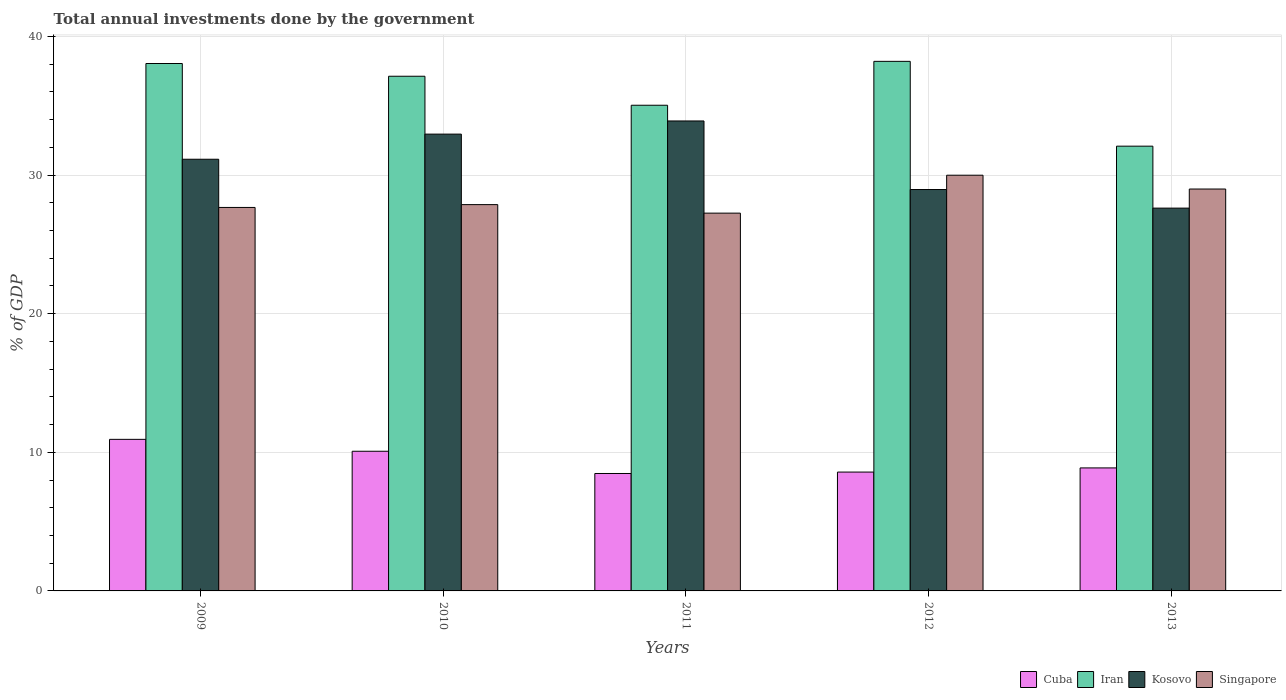Are the number of bars per tick equal to the number of legend labels?
Your answer should be very brief. Yes. Are the number of bars on each tick of the X-axis equal?
Keep it short and to the point. Yes. How many bars are there on the 5th tick from the left?
Ensure brevity in your answer.  4. How many bars are there on the 2nd tick from the right?
Give a very brief answer. 4. What is the total annual investments done by the government in Singapore in 2012?
Keep it short and to the point. 29.99. Across all years, what is the maximum total annual investments done by the government in Iran?
Keep it short and to the point. 38.21. Across all years, what is the minimum total annual investments done by the government in Singapore?
Offer a terse response. 27.26. What is the total total annual investments done by the government in Iran in the graph?
Offer a terse response. 180.51. What is the difference between the total annual investments done by the government in Cuba in 2009 and that in 2013?
Your response must be concise. 2.06. What is the difference between the total annual investments done by the government in Iran in 2011 and the total annual investments done by the government in Cuba in 2012?
Provide a succinct answer. 26.46. What is the average total annual investments done by the government in Kosovo per year?
Your answer should be compact. 30.92. In the year 2012, what is the difference between the total annual investments done by the government in Singapore and total annual investments done by the government in Cuba?
Offer a very short reply. 21.42. What is the ratio of the total annual investments done by the government in Singapore in 2009 to that in 2013?
Offer a very short reply. 0.95. Is the difference between the total annual investments done by the government in Singapore in 2012 and 2013 greater than the difference between the total annual investments done by the government in Cuba in 2012 and 2013?
Ensure brevity in your answer.  Yes. What is the difference between the highest and the second highest total annual investments done by the government in Iran?
Your response must be concise. 0.16. What is the difference between the highest and the lowest total annual investments done by the government in Singapore?
Give a very brief answer. 2.74. In how many years, is the total annual investments done by the government in Kosovo greater than the average total annual investments done by the government in Kosovo taken over all years?
Offer a terse response. 3. What does the 1st bar from the left in 2010 represents?
Your response must be concise. Cuba. What does the 4th bar from the right in 2011 represents?
Give a very brief answer. Cuba. Is it the case that in every year, the sum of the total annual investments done by the government in Iran and total annual investments done by the government in Singapore is greater than the total annual investments done by the government in Kosovo?
Offer a terse response. Yes. Does the graph contain grids?
Your response must be concise. Yes. Where does the legend appear in the graph?
Your answer should be very brief. Bottom right. How are the legend labels stacked?
Give a very brief answer. Horizontal. What is the title of the graph?
Offer a terse response. Total annual investments done by the government. What is the label or title of the X-axis?
Provide a succinct answer. Years. What is the label or title of the Y-axis?
Offer a terse response. % of GDP. What is the % of GDP in Cuba in 2009?
Your answer should be very brief. 10.93. What is the % of GDP of Iran in 2009?
Keep it short and to the point. 38.05. What is the % of GDP of Kosovo in 2009?
Offer a terse response. 31.14. What is the % of GDP of Singapore in 2009?
Your answer should be very brief. 27.67. What is the % of GDP of Cuba in 2010?
Keep it short and to the point. 10.08. What is the % of GDP in Iran in 2010?
Ensure brevity in your answer.  37.13. What is the % of GDP in Kosovo in 2010?
Keep it short and to the point. 32.96. What is the % of GDP of Singapore in 2010?
Make the answer very short. 27.87. What is the % of GDP in Cuba in 2011?
Make the answer very short. 8.47. What is the % of GDP of Iran in 2011?
Ensure brevity in your answer.  35.04. What is the % of GDP of Kosovo in 2011?
Offer a very short reply. 33.91. What is the % of GDP in Singapore in 2011?
Offer a very short reply. 27.26. What is the % of GDP in Cuba in 2012?
Your answer should be very brief. 8.57. What is the % of GDP of Iran in 2012?
Ensure brevity in your answer.  38.21. What is the % of GDP of Kosovo in 2012?
Your answer should be very brief. 28.96. What is the % of GDP in Singapore in 2012?
Ensure brevity in your answer.  29.99. What is the % of GDP of Cuba in 2013?
Make the answer very short. 8.87. What is the % of GDP in Iran in 2013?
Ensure brevity in your answer.  32.09. What is the % of GDP of Kosovo in 2013?
Ensure brevity in your answer.  27.62. What is the % of GDP of Singapore in 2013?
Make the answer very short. 29. Across all years, what is the maximum % of GDP in Cuba?
Make the answer very short. 10.93. Across all years, what is the maximum % of GDP in Iran?
Provide a short and direct response. 38.21. Across all years, what is the maximum % of GDP of Kosovo?
Offer a very short reply. 33.91. Across all years, what is the maximum % of GDP of Singapore?
Give a very brief answer. 29.99. Across all years, what is the minimum % of GDP of Cuba?
Your response must be concise. 8.47. Across all years, what is the minimum % of GDP of Iran?
Your answer should be very brief. 32.09. Across all years, what is the minimum % of GDP in Kosovo?
Make the answer very short. 27.62. Across all years, what is the minimum % of GDP in Singapore?
Offer a terse response. 27.26. What is the total % of GDP of Cuba in the graph?
Make the answer very short. 46.93. What is the total % of GDP in Iran in the graph?
Give a very brief answer. 180.51. What is the total % of GDP of Kosovo in the graph?
Your response must be concise. 154.58. What is the total % of GDP of Singapore in the graph?
Give a very brief answer. 141.78. What is the difference between the % of GDP in Cuba in 2009 and that in 2010?
Keep it short and to the point. 0.86. What is the difference between the % of GDP of Iran in 2009 and that in 2010?
Your response must be concise. 0.92. What is the difference between the % of GDP in Kosovo in 2009 and that in 2010?
Ensure brevity in your answer.  -1.81. What is the difference between the % of GDP in Singapore in 2009 and that in 2010?
Keep it short and to the point. -0.2. What is the difference between the % of GDP of Cuba in 2009 and that in 2011?
Keep it short and to the point. 2.46. What is the difference between the % of GDP of Iran in 2009 and that in 2011?
Offer a very short reply. 3.01. What is the difference between the % of GDP in Kosovo in 2009 and that in 2011?
Ensure brevity in your answer.  -2.76. What is the difference between the % of GDP in Singapore in 2009 and that in 2011?
Ensure brevity in your answer.  0.41. What is the difference between the % of GDP of Cuba in 2009 and that in 2012?
Ensure brevity in your answer.  2.36. What is the difference between the % of GDP of Iran in 2009 and that in 2012?
Offer a terse response. -0.16. What is the difference between the % of GDP in Kosovo in 2009 and that in 2012?
Your answer should be very brief. 2.18. What is the difference between the % of GDP in Singapore in 2009 and that in 2012?
Offer a terse response. -2.33. What is the difference between the % of GDP in Cuba in 2009 and that in 2013?
Provide a short and direct response. 2.06. What is the difference between the % of GDP in Iran in 2009 and that in 2013?
Offer a terse response. 5.96. What is the difference between the % of GDP in Kosovo in 2009 and that in 2013?
Give a very brief answer. 3.53. What is the difference between the % of GDP in Singapore in 2009 and that in 2013?
Your response must be concise. -1.33. What is the difference between the % of GDP in Cuba in 2010 and that in 2011?
Offer a very short reply. 1.6. What is the difference between the % of GDP of Iran in 2010 and that in 2011?
Ensure brevity in your answer.  2.09. What is the difference between the % of GDP in Kosovo in 2010 and that in 2011?
Make the answer very short. -0.95. What is the difference between the % of GDP of Singapore in 2010 and that in 2011?
Give a very brief answer. 0.61. What is the difference between the % of GDP of Cuba in 2010 and that in 2012?
Give a very brief answer. 1.5. What is the difference between the % of GDP in Iran in 2010 and that in 2012?
Provide a succinct answer. -1.07. What is the difference between the % of GDP of Kosovo in 2010 and that in 2012?
Offer a very short reply. 4. What is the difference between the % of GDP of Singapore in 2010 and that in 2012?
Keep it short and to the point. -2.12. What is the difference between the % of GDP of Cuba in 2010 and that in 2013?
Offer a very short reply. 1.2. What is the difference between the % of GDP in Iran in 2010 and that in 2013?
Make the answer very short. 5.04. What is the difference between the % of GDP in Kosovo in 2010 and that in 2013?
Give a very brief answer. 5.34. What is the difference between the % of GDP of Singapore in 2010 and that in 2013?
Offer a terse response. -1.13. What is the difference between the % of GDP of Cuba in 2011 and that in 2012?
Ensure brevity in your answer.  -0.1. What is the difference between the % of GDP in Iran in 2011 and that in 2012?
Your answer should be very brief. -3.17. What is the difference between the % of GDP in Kosovo in 2011 and that in 2012?
Keep it short and to the point. 4.95. What is the difference between the % of GDP of Singapore in 2011 and that in 2012?
Ensure brevity in your answer.  -2.74. What is the difference between the % of GDP in Cuba in 2011 and that in 2013?
Your answer should be compact. -0.4. What is the difference between the % of GDP in Iran in 2011 and that in 2013?
Offer a terse response. 2.95. What is the difference between the % of GDP in Kosovo in 2011 and that in 2013?
Your response must be concise. 6.29. What is the difference between the % of GDP of Singapore in 2011 and that in 2013?
Your answer should be compact. -1.74. What is the difference between the % of GDP in Cuba in 2012 and that in 2013?
Provide a succinct answer. -0.3. What is the difference between the % of GDP of Iran in 2012 and that in 2013?
Keep it short and to the point. 6.12. What is the difference between the % of GDP of Kosovo in 2012 and that in 2013?
Offer a terse response. 1.34. What is the difference between the % of GDP in Cuba in 2009 and the % of GDP in Iran in 2010?
Provide a succinct answer. -26.2. What is the difference between the % of GDP in Cuba in 2009 and the % of GDP in Kosovo in 2010?
Keep it short and to the point. -22.02. What is the difference between the % of GDP in Cuba in 2009 and the % of GDP in Singapore in 2010?
Make the answer very short. -16.93. What is the difference between the % of GDP in Iran in 2009 and the % of GDP in Kosovo in 2010?
Ensure brevity in your answer.  5.09. What is the difference between the % of GDP in Iran in 2009 and the % of GDP in Singapore in 2010?
Offer a very short reply. 10.18. What is the difference between the % of GDP of Kosovo in 2009 and the % of GDP of Singapore in 2010?
Ensure brevity in your answer.  3.27. What is the difference between the % of GDP of Cuba in 2009 and the % of GDP of Iran in 2011?
Your response must be concise. -24.1. What is the difference between the % of GDP of Cuba in 2009 and the % of GDP of Kosovo in 2011?
Your answer should be compact. -22.97. What is the difference between the % of GDP in Cuba in 2009 and the % of GDP in Singapore in 2011?
Offer a very short reply. -16.32. What is the difference between the % of GDP of Iran in 2009 and the % of GDP of Kosovo in 2011?
Give a very brief answer. 4.14. What is the difference between the % of GDP of Iran in 2009 and the % of GDP of Singapore in 2011?
Your answer should be compact. 10.79. What is the difference between the % of GDP in Kosovo in 2009 and the % of GDP in Singapore in 2011?
Offer a very short reply. 3.89. What is the difference between the % of GDP of Cuba in 2009 and the % of GDP of Iran in 2012?
Your answer should be very brief. -27.27. What is the difference between the % of GDP of Cuba in 2009 and the % of GDP of Kosovo in 2012?
Offer a very short reply. -18.02. What is the difference between the % of GDP in Cuba in 2009 and the % of GDP in Singapore in 2012?
Your answer should be compact. -19.06. What is the difference between the % of GDP in Iran in 2009 and the % of GDP in Kosovo in 2012?
Provide a short and direct response. 9.09. What is the difference between the % of GDP of Iran in 2009 and the % of GDP of Singapore in 2012?
Your answer should be very brief. 8.06. What is the difference between the % of GDP of Kosovo in 2009 and the % of GDP of Singapore in 2012?
Ensure brevity in your answer.  1.15. What is the difference between the % of GDP in Cuba in 2009 and the % of GDP in Iran in 2013?
Make the answer very short. -21.15. What is the difference between the % of GDP in Cuba in 2009 and the % of GDP in Kosovo in 2013?
Your answer should be compact. -16.68. What is the difference between the % of GDP in Cuba in 2009 and the % of GDP in Singapore in 2013?
Keep it short and to the point. -18.06. What is the difference between the % of GDP in Iran in 2009 and the % of GDP in Kosovo in 2013?
Offer a very short reply. 10.43. What is the difference between the % of GDP of Iran in 2009 and the % of GDP of Singapore in 2013?
Offer a very short reply. 9.05. What is the difference between the % of GDP of Kosovo in 2009 and the % of GDP of Singapore in 2013?
Give a very brief answer. 2.15. What is the difference between the % of GDP in Cuba in 2010 and the % of GDP in Iran in 2011?
Keep it short and to the point. -24.96. What is the difference between the % of GDP of Cuba in 2010 and the % of GDP of Kosovo in 2011?
Make the answer very short. -23.83. What is the difference between the % of GDP of Cuba in 2010 and the % of GDP of Singapore in 2011?
Provide a short and direct response. -17.18. What is the difference between the % of GDP in Iran in 2010 and the % of GDP in Kosovo in 2011?
Ensure brevity in your answer.  3.23. What is the difference between the % of GDP of Iran in 2010 and the % of GDP of Singapore in 2011?
Your answer should be very brief. 9.88. What is the difference between the % of GDP in Kosovo in 2010 and the % of GDP in Singapore in 2011?
Your response must be concise. 5.7. What is the difference between the % of GDP of Cuba in 2010 and the % of GDP of Iran in 2012?
Your response must be concise. -28.13. What is the difference between the % of GDP of Cuba in 2010 and the % of GDP of Kosovo in 2012?
Offer a terse response. -18.88. What is the difference between the % of GDP in Cuba in 2010 and the % of GDP in Singapore in 2012?
Provide a succinct answer. -19.91. What is the difference between the % of GDP in Iran in 2010 and the % of GDP in Kosovo in 2012?
Provide a succinct answer. 8.17. What is the difference between the % of GDP of Iran in 2010 and the % of GDP of Singapore in 2012?
Your response must be concise. 7.14. What is the difference between the % of GDP of Kosovo in 2010 and the % of GDP of Singapore in 2012?
Provide a succinct answer. 2.97. What is the difference between the % of GDP in Cuba in 2010 and the % of GDP in Iran in 2013?
Your response must be concise. -22.01. What is the difference between the % of GDP in Cuba in 2010 and the % of GDP in Kosovo in 2013?
Offer a terse response. -17.54. What is the difference between the % of GDP in Cuba in 2010 and the % of GDP in Singapore in 2013?
Offer a very short reply. -18.92. What is the difference between the % of GDP of Iran in 2010 and the % of GDP of Kosovo in 2013?
Your answer should be compact. 9.51. What is the difference between the % of GDP in Iran in 2010 and the % of GDP in Singapore in 2013?
Your answer should be compact. 8.14. What is the difference between the % of GDP of Kosovo in 2010 and the % of GDP of Singapore in 2013?
Your answer should be compact. 3.96. What is the difference between the % of GDP of Cuba in 2011 and the % of GDP of Iran in 2012?
Offer a very short reply. -29.73. What is the difference between the % of GDP of Cuba in 2011 and the % of GDP of Kosovo in 2012?
Provide a short and direct response. -20.49. What is the difference between the % of GDP of Cuba in 2011 and the % of GDP of Singapore in 2012?
Keep it short and to the point. -21.52. What is the difference between the % of GDP of Iran in 2011 and the % of GDP of Kosovo in 2012?
Ensure brevity in your answer.  6.08. What is the difference between the % of GDP in Iran in 2011 and the % of GDP in Singapore in 2012?
Ensure brevity in your answer.  5.05. What is the difference between the % of GDP of Kosovo in 2011 and the % of GDP of Singapore in 2012?
Your answer should be compact. 3.91. What is the difference between the % of GDP in Cuba in 2011 and the % of GDP in Iran in 2013?
Offer a terse response. -23.62. What is the difference between the % of GDP in Cuba in 2011 and the % of GDP in Kosovo in 2013?
Provide a short and direct response. -19.15. What is the difference between the % of GDP in Cuba in 2011 and the % of GDP in Singapore in 2013?
Keep it short and to the point. -20.52. What is the difference between the % of GDP of Iran in 2011 and the % of GDP of Kosovo in 2013?
Offer a terse response. 7.42. What is the difference between the % of GDP in Iran in 2011 and the % of GDP in Singapore in 2013?
Your answer should be very brief. 6.04. What is the difference between the % of GDP in Kosovo in 2011 and the % of GDP in Singapore in 2013?
Offer a very short reply. 4.91. What is the difference between the % of GDP in Cuba in 2012 and the % of GDP in Iran in 2013?
Give a very brief answer. -23.51. What is the difference between the % of GDP of Cuba in 2012 and the % of GDP of Kosovo in 2013?
Make the answer very short. -19.04. What is the difference between the % of GDP in Cuba in 2012 and the % of GDP in Singapore in 2013?
Provide a succinct answer. -20.42. What is the difference between the % of GDP of Iran in 2012 and the % of GDP of Kosovo in 2013?
Give a very brief answer. 10.59. What is the difference between the % of GDP in Iran in 2012 and the % of GDP in Singapore in 2013?
Keep it short and to the point. 9.21. What is the difference between the % of GDP of Kosovo in 2012 and the % of GDP of Singapore in 2013?
Make the answer very short. -0.04. What is the average % of GDP in Cuba per year?
Your answer should be compact. 9.39. What is the average % of GDP of Iran per year?
Your answer should be compact. 36.1. What is the average % of GDP in Kosovo per year?
Your answer should be compact. 30.92. What is the average % of GDP in Singapore per year?
Your response must be concise. 28.36. In the year 2009, what is the difference between the % of GDP of Cuba and % of GDP of Iran?
Make the answer very short. -27.11. In the year 2009, what is the difference between the % of GDP of Cuba and % of GDP of Kosovo?
Provide a succinct answer. -20.21. In the year 2009, what is the difference between the % of GDP of Cuba and % of GDP of Singapore?
Offer a terse response. -16.73. In the year 2009, what is the difference between the % of GDP in Iran and % of GDP in Kosovo?
Offer a very short reply. 6.91. In the year 2009, what is the difference between the % of GDP in Iran and % of GDP in Singapore?
Offer a terse response. 10.38. In the year 2009, what is the difference between the % of GDP of Kosovo and % of GDP of Singapore?
Provide a short and direct response. 3.48. In the year 2010, what is the difference between the % of GDP in Cuba and % of GDP in Iran?
Give a very brief answer. -27.05. In the year 2010, what is the difference between the % of GDP of Cuba and % of GDP of Kosovo?
Your answer should be compact. -22.88. In the year 2010, what is the difference between the % of GDP of Cuba and % of GDP of Singapore?
Your answer should be compact. -17.79. In the year 2010, what is the difference between the % of GDP of Iran and % of GDP of Kosovo?
Your response must be concise. 4.18. In the year 2010, what is the difference between the % of GDP of Iran and % of GDP of Singapore?
Provide a short and direct response. 9.26. In the year 2010, what is the difference between the % of GDP in Kosovo and % of GDP in Singapore?
Your response must be concise. 5.09. In the year 2011, what is the difference between the % of GDP of Cuba and % of GDP of Iran?
Give a very brief answer. -26.57. In the year 2011, what is the difference between the % of GDP in Cuba and % of GDP in Kosovo?
Provide a succinct answer. -25.43. In the year 2011, what is the difference between the % of GDP of Cuba and % of GDP of Singapore?
Make the answer very short. -18.78. In the year 2011, what is the difference between the % of GDP in Iran and % of GDP in Kosovo?
Make the answer very short. 1.13. In the year 2011, what is the difference between the % of GDP of Iran and % of GDP of Singapore?
Offer a terse response. 7.78. In the year 2011, what is the difference between the % of GDP of Kosovo and % of GDP of Singapore?
Keep it short and to the point. 6.65. In the year 2012, what is the difference between the % of GDP in Cuba and % of GDP in Iran?
Offer a very short reply. -29.63. In the year 2012, what is the difference between the % of GDP of Cuba and % of GDP of Kosovo?
Offer a terse response. -20.38. In the year 2012, what is the difference between the % of GDP of Cuba and % of GDP of Singapore?
Offer a terse response. -21.42. In the year 2012, what is the difference between the % of GDP in Iran and % of GDP in Kosovo?
Offer a terse response. 9.25. In the year 2012, what is the difference between the % of GDP in Iran and % of GDP in Singapore?
Provide a succinct answer. 8.21. In the year 2012, what is the difference between the % of GDP of Kosovo and % of GDP of Singapore?
Ensure brevity in your answer.  -1.03. In the year 2013, what is the difference between the % of GDP of Cuba and % of GDP of Iran?
Offer a very short reply. -23.21. In the year 2013, what is the difference between the % of GDP in Cuba and % of GDP in Kosovo?
Your response must be concise. -18.74. In the year 2013, what is the difference between the % of GDP of Cuba and % of GDP of Singapore?
Your answer should be very brief. -20.12. In the year 2013, what is the difference between the % of GDP of Iran and % of GDP of Kosovo?
Your answer should be compact. 4.47. In the year 2013, what is the difference between the % of GDP in Iran and % of GDP in Singapore?
Provide a short and direct response. 3.09. In the year 2013, what is the difference between the % of GDP of Kosovo and % of GDP of Singapore?
Ensure brevity in your answer.  -1.38. What is the ratio of the % of GDP of Cuba in 2009 to that in 2010?
Your answer should be very brief. 1.09. What is the ratio of the % of GDP in Iran in 2009 to that in 2010?
Offer a terse response. 1.02. What is the ratio of the % of GDP in Kosovo in 2009 to that in 2010?
Your answer should be very brief. 0.94. What is the ratio of the % of GDP in Cuba in 2009 to that in 2011?
Offer a very short reply. 1.29. What is the ratio of the % of GDP of Iran in 2009 to that in 2011?
Give a very brief answer. 1.09. What is the ratio of the % of GDP in Kosovo in 2009 to that in 2011?
Ensure brevity in your answer.  0.92. What is the ratio of the % of GDP of Singapore in 2009 to that in 2011?
Offer a very short reply. 1.02. What is the ratio of the % of GDP of Cuba in 2009 to that in 2012?
Your answer should be very brief. 1.28. What is the ratio of the % of GDP in Iran in 2009 to that in 2012?
Your answer should be compact. 1. What is the ratio of the % of GDP of Kosovo in 2009 to that in 2012?
Ensure brevity in your answer.  1.08. What is the ratio of the % of GDP of Singapore in 2009 to that in 2012?
Ensure brevity in your answer.  0.92. What is the ratio of the % of GDP of Cuba in 2009 to that in 2013?
Ensure brevity in your answer.  1.23. What is the ratio of the % of GDP of Iran in 2009 to that in 2013?
Your answer should be compact. 1.19. What is the ratio of the % of GDP of Kosovo in 2009 to that in 2013?
Provide a succinct answer. 1.13. What is the ratio of the % of GDP of Singapore in 2009 to that in 2013?
Give a very brief answer. 0.95. What is the ratio of the % of GDP of Cuba in 2010 to that in 2011?
Your response must be concise. 1.19. What is the ratio of the % of GDP in Iran in 2010 to that in 2011?
Give a very brief answer. 1.06. What is the ratio of the % of GDP in Singapore in 2010 to that in 2011?
Your answer should be very brief. 1.02. What is the ratio of the % of GDP of Cuba in 2010 to that in 2012?
Offer a very short reply. 1.18. What is the ratio of the % of GDP in Iran in 2010 to that in 2012?
Your response must be concise. 0.97. What is the ratio of the % of GDP in Kosovo in 2010 to that in 2012?
Your answer should be compact. 1.14. What is the ratio of the % of GDP in Singapore in 2010 to that in 2012?
Offer a very short reply. 0.93. What is the ratio of the % of GDP in Cuba in 2010 to that in 2013?
Your response must be concise. 1.14. What is the ratio of the % of GDP of Iran in 2010 to that in 2013?
Provide a short and direct response. 1.16. What is the ratio of the % of GDP of Kosovo in 2010 to that in 2013?
Your answer should be compact. 1.19. What is the ratio of the % of GDP of Singapore in 2010 to that in 2013?
Give a very brief answer. 0.96. What is the ratio of the % of GDP of Cuba in 2011 to that in 2012?
Provide a short and direct response. 0.99. What is the ratio of the % of GDP of Iran in 2011 to that in 2012?
Provide a succinct answer. 0.92. What is the ratio of the % of GDP of Kosovo in 2011 to that in 2012?
Your answer should be compact. 1.17. What is the ratio of the % of GDP in Singapore in 2011 to that in 2012?
Make the answer very short. 0.91. What is the ratio of the % of GDP of Cuba in 2011 to that in 2013?
Provide a succinct answer. 0.95. What is the ratio of the % of GDP in Iran in 2011 to that in 2013?
Your response must be concise. 1.09. What is the ratio of the % of GDP in Kosovo in 2011 to that in 2013?
Give a very brief answer. 1.23. What is the ratio of the % of GDP of Cuba in 2012 to that in 2013?
Provide a short and direct response. 0.97. What is the ratio of the % of GDP of Iran in 2012 to that in 2013?
Make the answer very short. 1.19. What is the ratio of the % of GDP in Kosovo in 2012 to that in 2013?
Keep it short and to the point. 1.05. What is the ratio of the % of GDP of Singapore in 2012 to that in 2013?
Your response must be concise. 1.03. What is the difference between the highest and the second highest % of GDP of Cuba?
Ensure brevity in your answer.  0.86. What is the difference between the highest and the second highest % of GDP of Iran?
Keep it short and to the point. 0.16. What is the difference between the highest and the second highest % of GDP in Kosovo?
Provide a short and direct response. 0.95. What is the difference between the highest and the second highest % of GDP in Singapore?
Keep it short and to the point. 1. What is the difference between the highest and the lowest % of GDP in Cuba?
Keep it short and to the point. 2.46. What is the difference between the highest and the lowest % of GDP of Iran?
Make the answer very short. 6.12. What is the difference between the highest and the lowest % of GDP in Kosovo?
Your response must be concise. 6.29. What is the difference between the highest and the lowest % of GDP in Singapore?
Give a very brief answer. 2.74. 